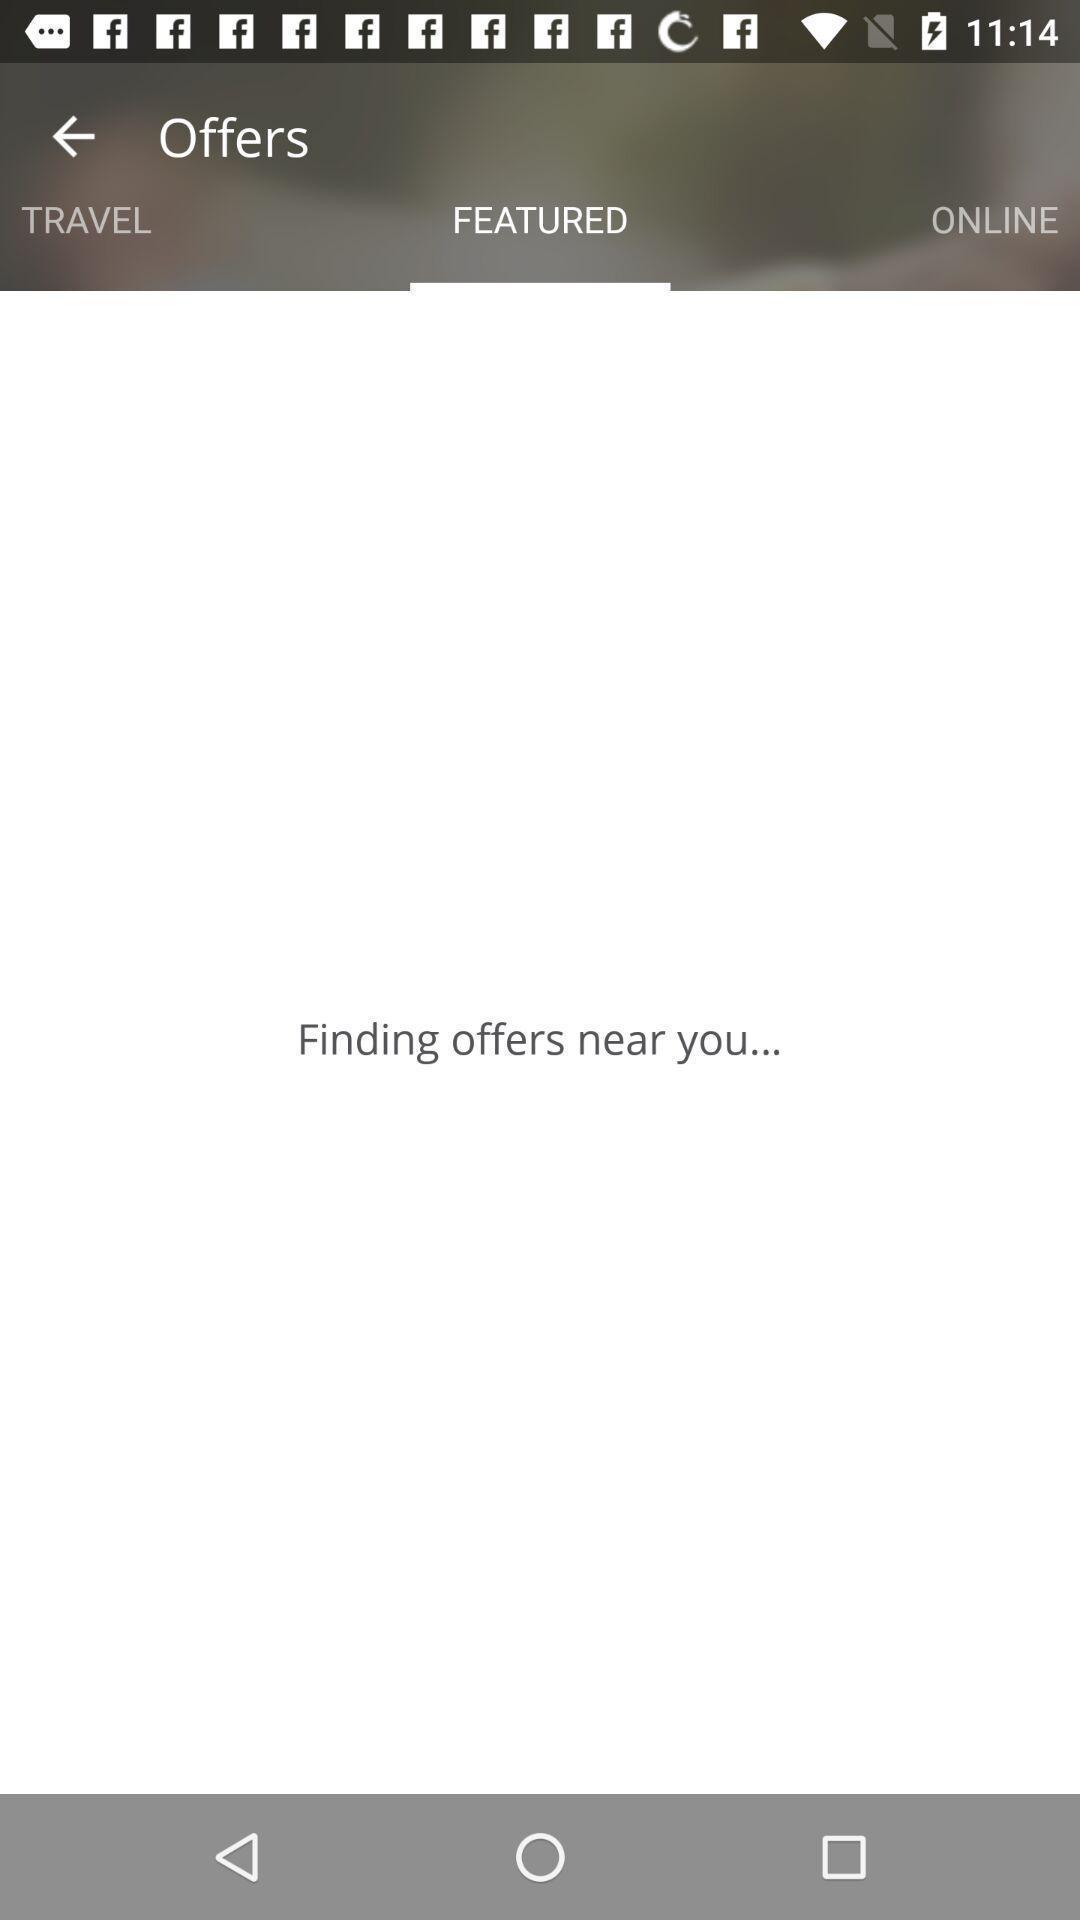Describe the visual elements of this screenshot. Offers status displaying in this page. 